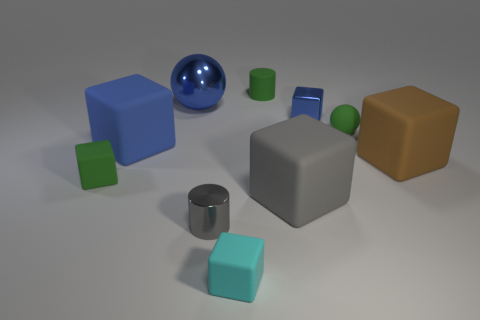What color is the tiny metal thing that is the same shape as the big brown rubber object?
Give a very brief answer. Blue. Is there any other thing that has the same shape as the gray shiny thing?
Make the answer very short. Yes. What color is the cylinder that is the same material as the big gray object?
Make the answer very short. Green. There is a tiny cyan thing to the left of the blue block right of the blue matte block; are there any cyan blocks that are behind it?
Your answer should be compact. No. Are there fewer small rubber objects to the left of the big shiny object than things in front of the brown matte object?
Offer a terse response. Yes. How many gray things are made of the same material as the blue ball?
Offer a terse response. 1. Is the size of the blue metallic ball the same as the blue metallic object in front of the metallic sphere?
Offer a very short reply. No. There is a ball that is the same color as the tiny shiny block; what is its material?
Ensure brevity in your answer.  Metal. How big is the shiny thing that is in front of the metallic thing on the right side of the tiny cyan thing in front of the rubber ball?
Offer a terse response. Small. Is the number of tiny shiny cylinders that are to the right of the cyan thing greater than the number of metal balls that are in front of the shiny sphere?
Your answer should be compact. No. 